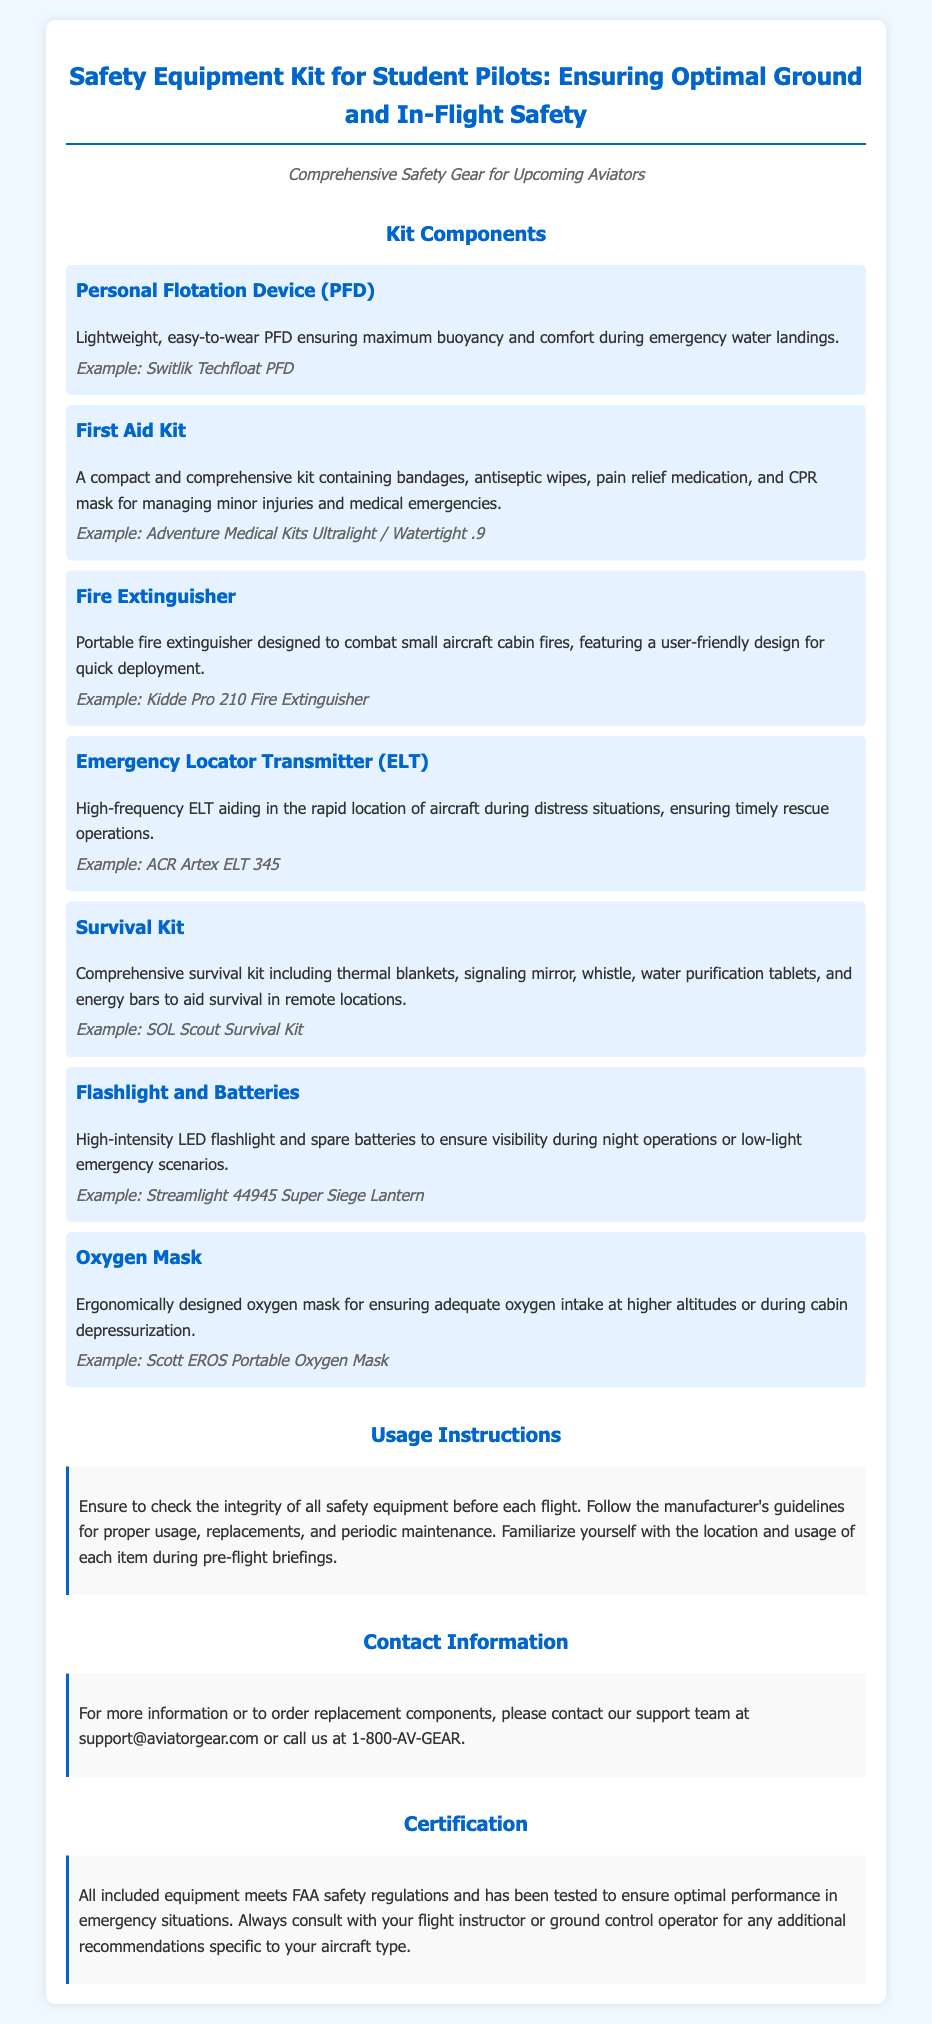What is the first item listed in the kit components? The first item listed is a Personal Flotation Device (PFD), which is mentioned at the beginning of the kit components section.
Answer: Personal Flotation Device (PFD) How many items are included in the kit components? There are a total of seven items listed in the kit components section.
Answer: 7 What does the First Aid Kit contain? The first aid kit contains bandages, antiseptic wipes, pain relief medication, and a CPR mask.
Answer: Bandages, antiseptic wipes, pain relief medication, CPR mask What is the purpose of the Emergency Locator Transmitter (ELT)? The ELT is designed to assist in the rapid location of aircraft during distress situations.
Answer: Rapid location of aircraft What should you do before each flight regarding safety equipment? You should check the integrity of all safety equipment before each flight.
Answer: Check the integrity Which item's example is a Switlik Techfloat? The example of the Switlik Techfloat refers to the Personal Flotation Device (PFD).
Answer: Personal Flotation Device (PFD) What is the contact email for more information on the kit? The contact email for more information about the kit is provided under Contact Information.
Answer: support@aviatorgear.com What certification do all included equipment meet? All included equipment meets FAA safety regulations.
Answer: FAA safety regulations 